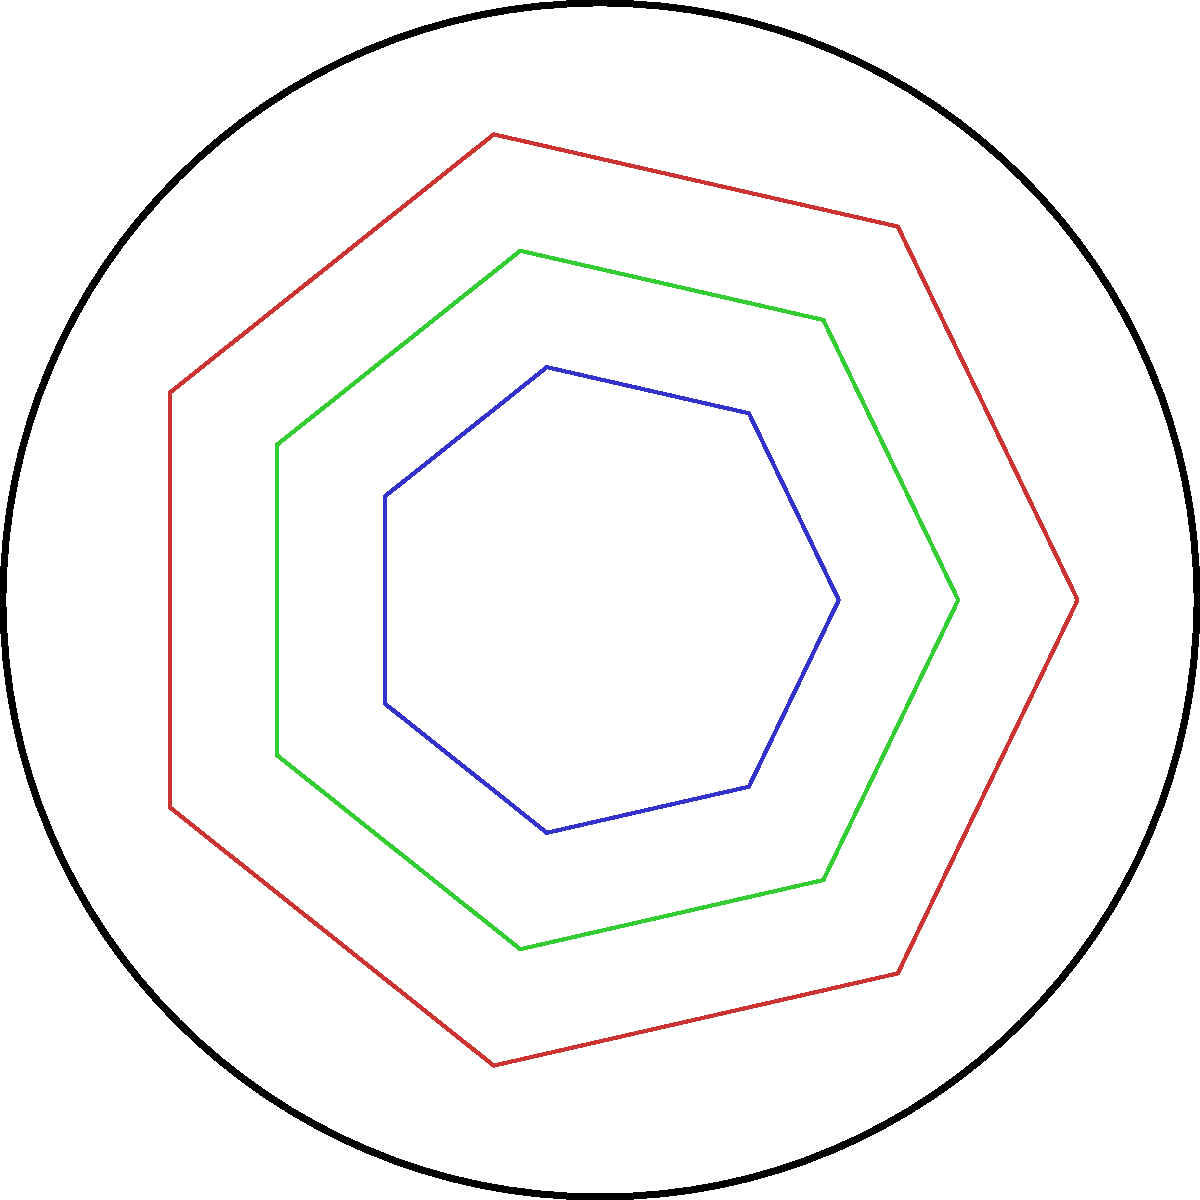In the context of traditional art patterns across cultures, which geometric principle is illustrated by the nested heptagonal shapes in this diagram, and how does it relate to non-Euclidean geometry? To answer this question, let's break it down step-by-step:

1. Observation: The diagram shows nested heptagonal (7-sided) shapes within a circle.

2. Euclidean vs. Non-Euclidean geometry:
   - Euclidean geometry is based on flat surfaces.
   - Non-Euclidean geometry involves curved surfaces.

3. Key feature: The heptagons appear to shrink as they approach the circle's edge.

4. Hyperbolic geometry:
   - A type of non-Euclidean geometry.
   - Represented on a disk where distances appear to increase towards the edge.

5. Poincaré disk model:
   - A way to visualize hyperbolic geometry in a Euclidean plane.
   - Shapes appear to shrink as they approach the boundary.

6. Cultural significance:
   - Similar patterns are found in various cultures' traditional art.
   - Examples: Islamic tessellations, Celtic knots, some Native American designs.

7. Relation to non-Euclidean geometry:
   - These art forms often intuitively represent concepts of infinite patterns and curved space.
   - They predate formal mathematical understanding of non-Euclidean geometry.

Therefore, this diagram illustrates the principle of hyperbolic geometry using the Poincaré disk model, which is related to traditional art patterns that intuitively represent non-Euclidean concepts.
Answer: Hyperbolic geometry (Poincaré disk model) 